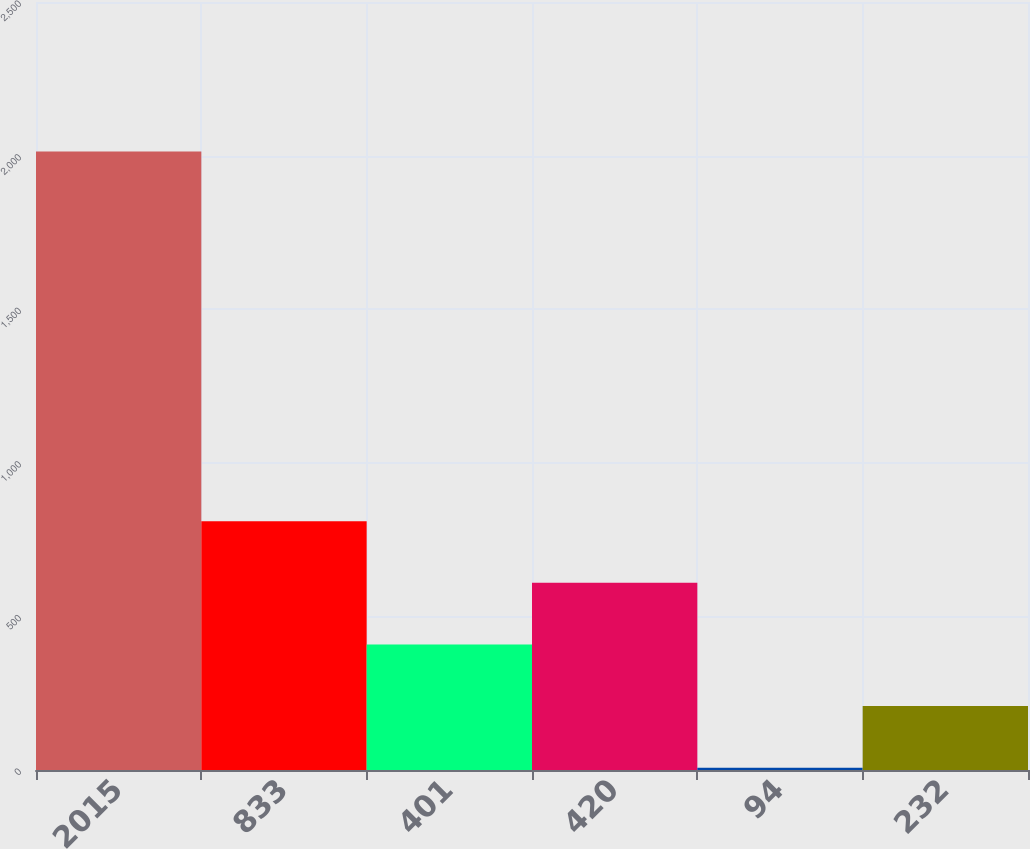<chart> <loc_0><loc_0><loc_500><loc_500><bar_chart><fcel>2015<fcel>833<fcel>401<fcel>420<fcel>94<fcel>232<nl><fcel>2013<fcel>809.7<fcel>408.6<fcel>609.15<fcel>7.5<fcel>208.05<nl></chart> 